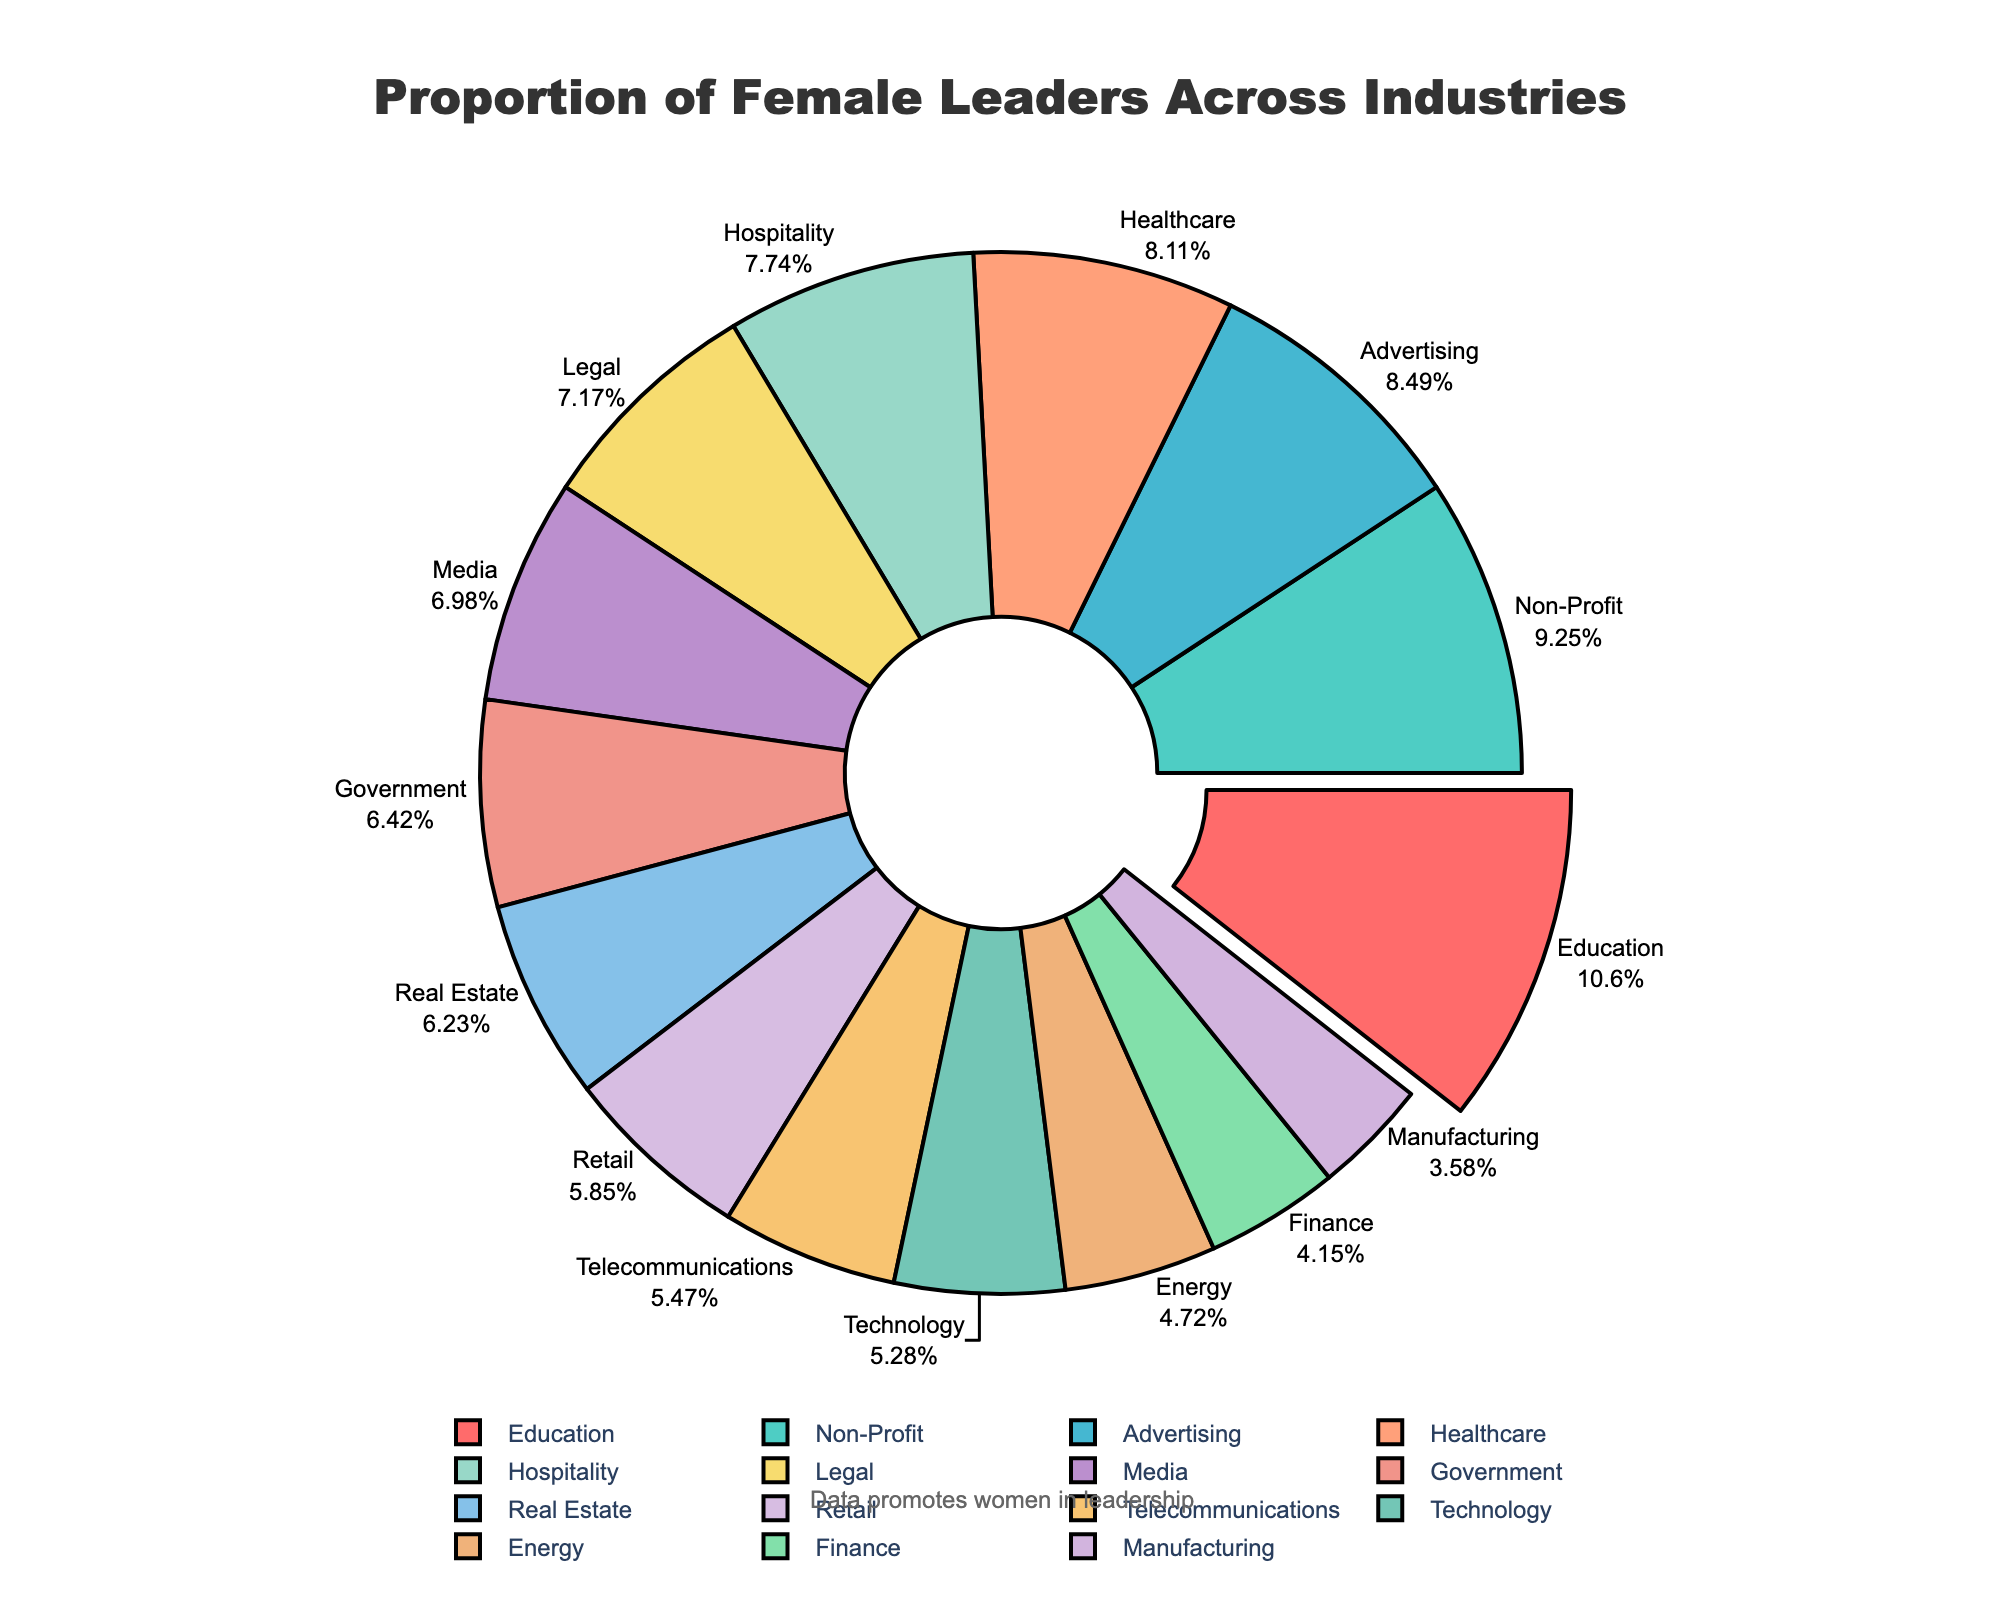Which industry has the highest proportion of female leaders? Look at the figure and identify the sector with the largest segment. Education has the highest proportion of female leaders at 56%.
Answer: Education Which industry has the lowest proportion of female leaders? Observe the chart and find the smallest segment. Manufacturing has the lowest proportion of female leaders at 19%.
Answer: Manufacturing How much higher is the proportion of female leaders in Healthcare compared to Finance? Find the data points for Healthcare and Finance. Healthcare is 43% and Finance is 22%. Subtract the Finance percentage from Healthcare’s: 43% - 22% = 21%.
Answer: 21% What is the total proportion of female leaders in Government and Technology combined? Locate Government and Technology percentages: 34% and 28%. Add them together: 34% + 28% = 62%.
Answer: 62% Which sector has a slightly lower proportion of female leaders than Media? Identify Media’s proportion at 37%, then find the adjacent lower proportion. Hospitality has a proportion of 41%, which is slightly lower than Media.
Answer: Hospitality What is the average percentage of female leaders in the Advertising, Legal, and Communications industries? Find the percentages for the three industries: Advertising (45%), Legal (38%), and Telecommunications (29%). Sum them: 45% + 38% + 29% = 112%, and divide by 3: 112% ÷ 3 = 37.33%.
Answer: 37.33% Is the proportion of female leaders in Non-Profit organizations greater than in Retail sectors? Compare Non-Profit (49%) to Retail (31%). Since 49% > 31%, the proportion is greater in Non-Profit.
Answer: Yes Which industry follows Education in having the next highest proportion of female leaders? See Education at 56%. The next largest segment is from Non-Profit at 49%.
Answer: Non-Profit How does the proportion of female leaders in Real Estate compare to Government? Look for Real Estate’s proportion at 33% and Government's at 34%. Real Estate is 1% lower than Government.
Answer: Lower What is the median proportion of female leaders among all the industries listed? First, list all the proportions in ascending order: 19%, 22%, 25%, 28%, 29%, 31%, 33%, 34%, 37%, 38%, 41%, 43%, 45%, 49%, 56%. The median is the middle value, which is 34%.
Answer: 34% 